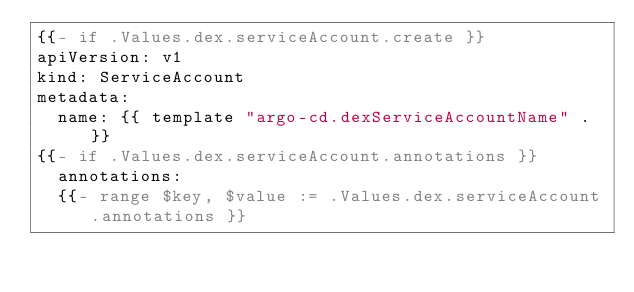<code> <loc_0><loc_0><loc_500><loc_500><_YAML_>{{- if .Values.dex.serviceAccount.create }}
apiVersion: v1
kind: ServiceAccount
metadata:
  name: {{ template "argo-cd.dexServiceAccountName" . }}
{{- if .Values.dex.serviceAccount.annotations }}
  annotations:
  {{- range $key, $value := .Values.dex.serviceAccount.annotations }}</code> 